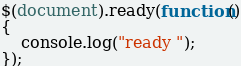<code> <loc_0><loc_0><loc_500><loc_500><_JavaScript_>$(document).ready(function()
{
    console.log("ready ");
});</code> 